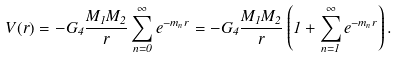<formula> <loc_0><loc_0><loc_500><loc_500>V ( r ) = - G _ { 4 } \frac { M _ { 1 } M _ { 2 } } { r } \sum _ { n = 0 } ^ { \infty } e ^ { - m _ { n } r } = - G _ { 4 } \frac { M _ { 1 } M _ { 2 } } { r } \left ( 1 + \sum _ { n = 1 } ^ { \infty } e ^ { - m _ { n } r } \right ) .</formula> 